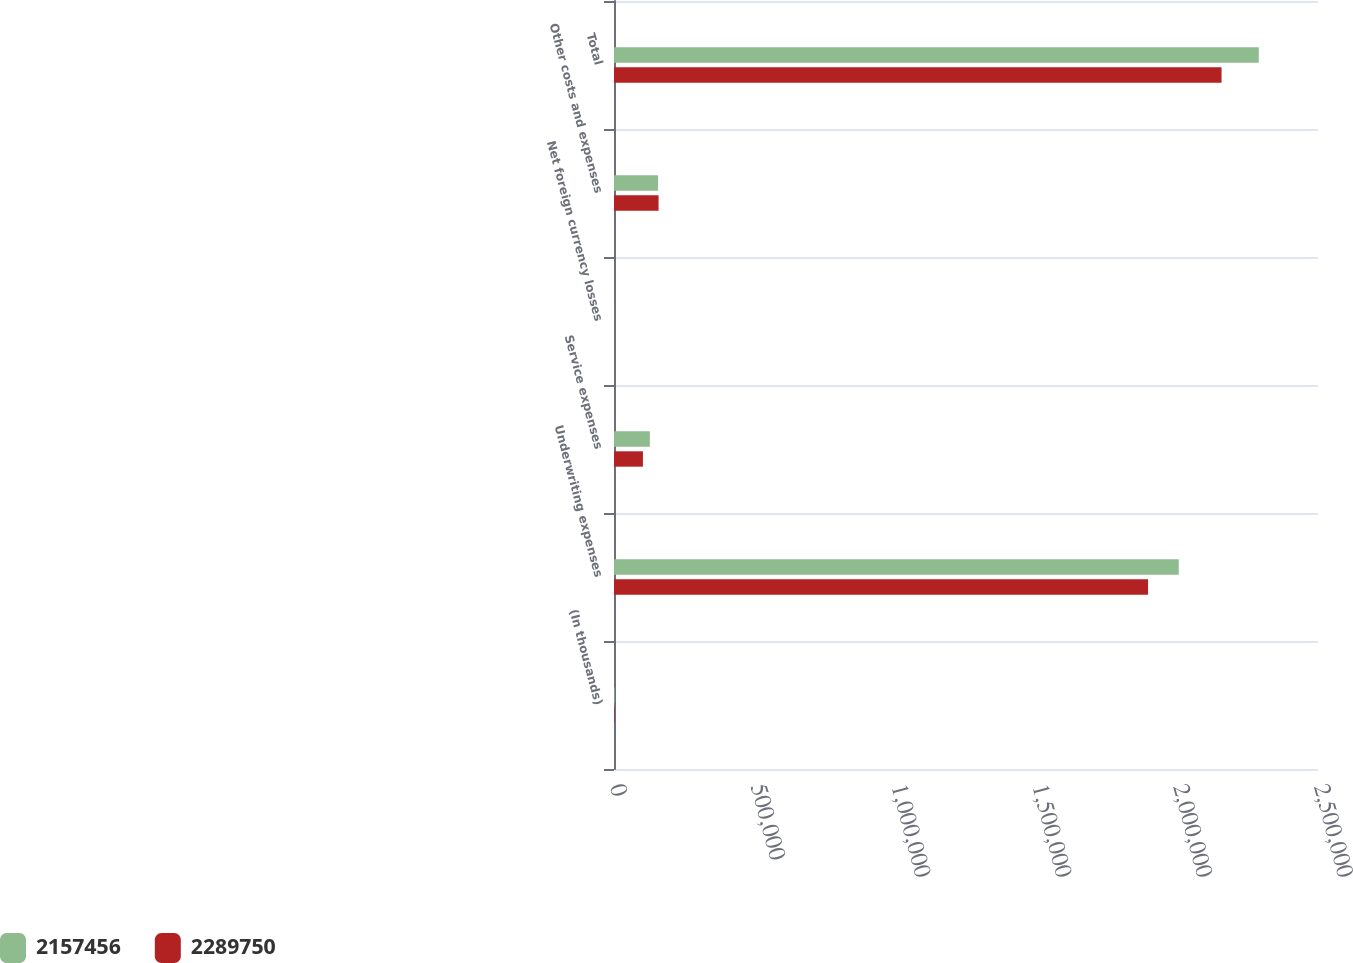Convert chart. <chart><loc_0><loc_0><loc_500><loc_500><stacked_bar_chart><ecel><fcel>(In thousands)<fcel>Underwriting expenses<fcel>Service expenses<fcel>Net foreign currency losses<fcel>Other costs and expenses<fcel>Total<nl><fcel>2.15746e+06<fcel>2015<fcel>2.0055e+06<fcel>127365<fcel>400<fcel>156487<fcel>2.28975e+06<nl><fcel>2.28975e+06<fcel>2014<fcel>1.89653e+06<fcel>102726<fcel>27<fcel>158227<fcel>2.15746e+06<nl></chart> 